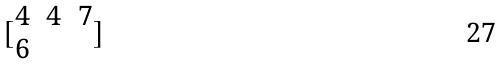Convert formula to latex. <formula><loc_0><loc_0><loc_500><loc_500>[ \begin{matrix} 4 & 4 & 7 \\ 6 \end{matrix} ]</formula> 